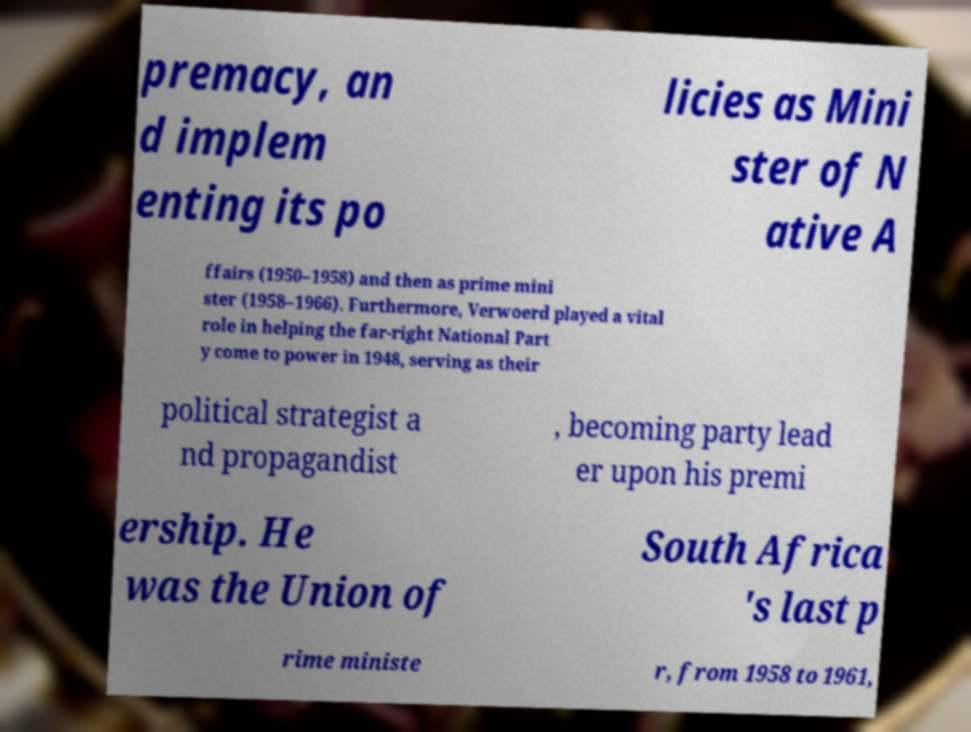Can you read and provide the text displayed in the image?This photo seems to have some interesting text. Can you extract and type it out for me? premacy, an d implem enting its po licies as Mini ster of N ative A ffairs (1950–1958) and then as prime mini ster (1958–1966). Furthermore, Verwoerd played a vital role in helping the far-right National Part y come to power in 1948, serving as their political strategist a nd propagandist , becoming party lead er upon his premi ership. He was the Union of South Africa 's last p rime ministe r, from 1958 to 1961, 